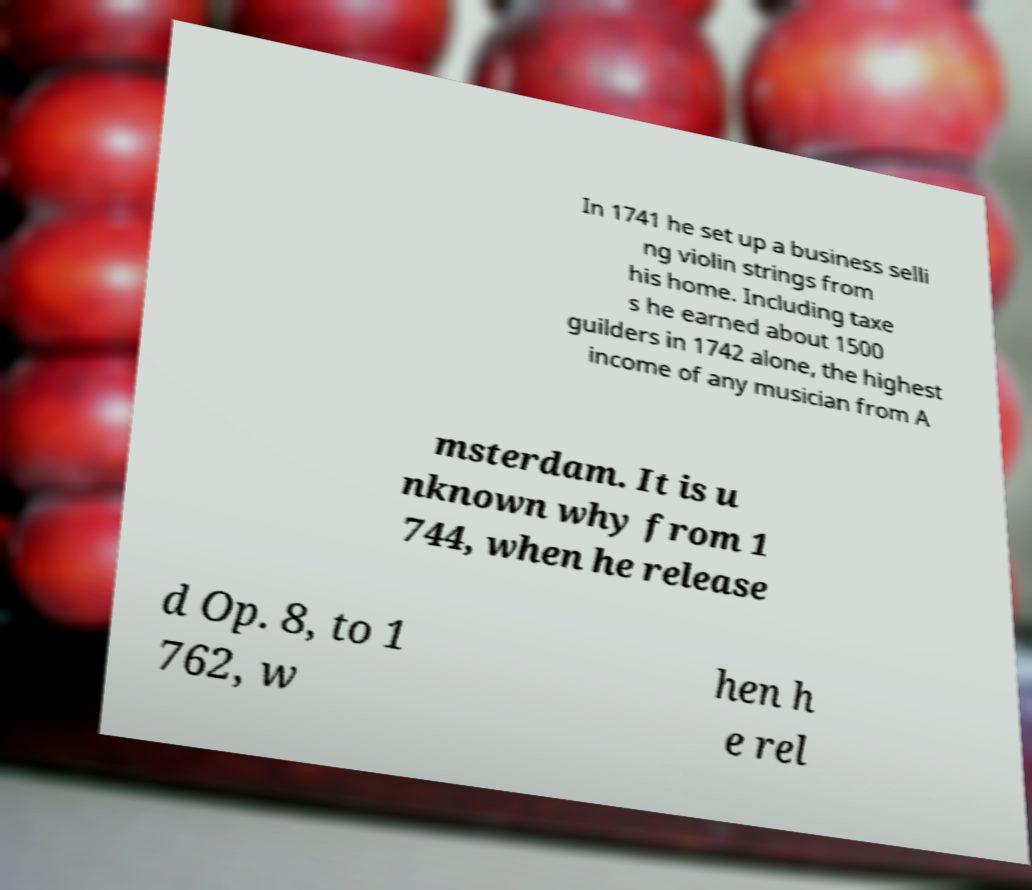For documentation purposes, I need the text within this image transcribed. Could you provide that? In 1741 he set up a business selli ng violin strings from his home. Including taxe s he earned about 1500 guilders in 1742 alone, the highest income of any musician from A msterdam. It is u nknown why from 1 744, when he release d Op. 8, to 1 762, w hen h e rel 